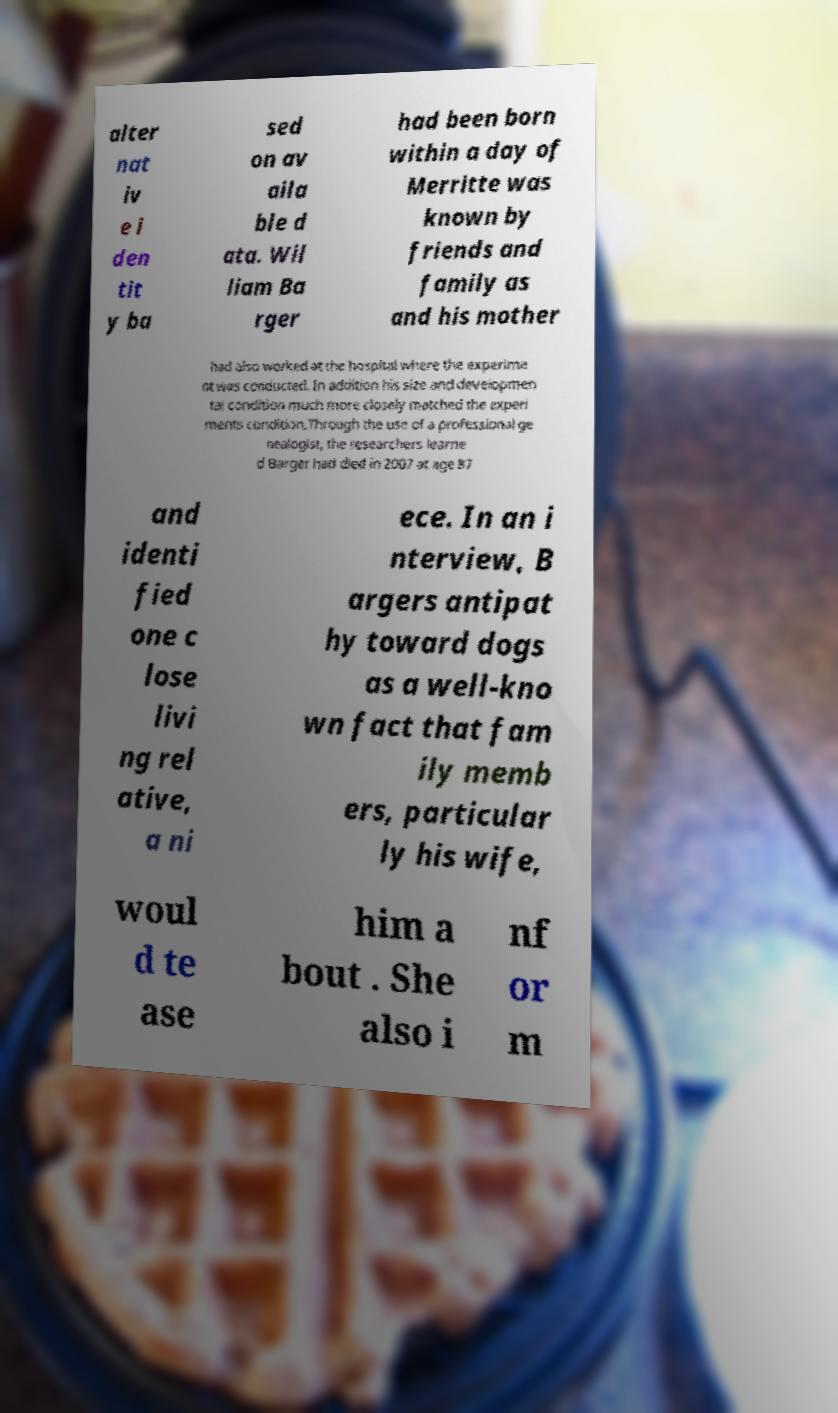For documentation purposes, I need the text within this image transcribed. Could you provide that? alter nat iv e i den tit y ba sed on av aila ble d ata. Wil liam Ba rger had been born within a day of Merritte was known by friends and family as and his mother had also worked at the hospital where the experime nt was conducted. In addition his size and developmen tal condition much more closely matched the experi ments condition.Through the use of a professional ge nealogist, the researchers learne d Barger had died in 2007 at age 87 and identi fied one c lose livi ng rel ative, a ni ece. In an i nterview, B argers antipat hy toward dogs as a well-kno wn fact that fam ily memb ers, particular ly his wife, woul d te ase him a bout . She also i nf or m 